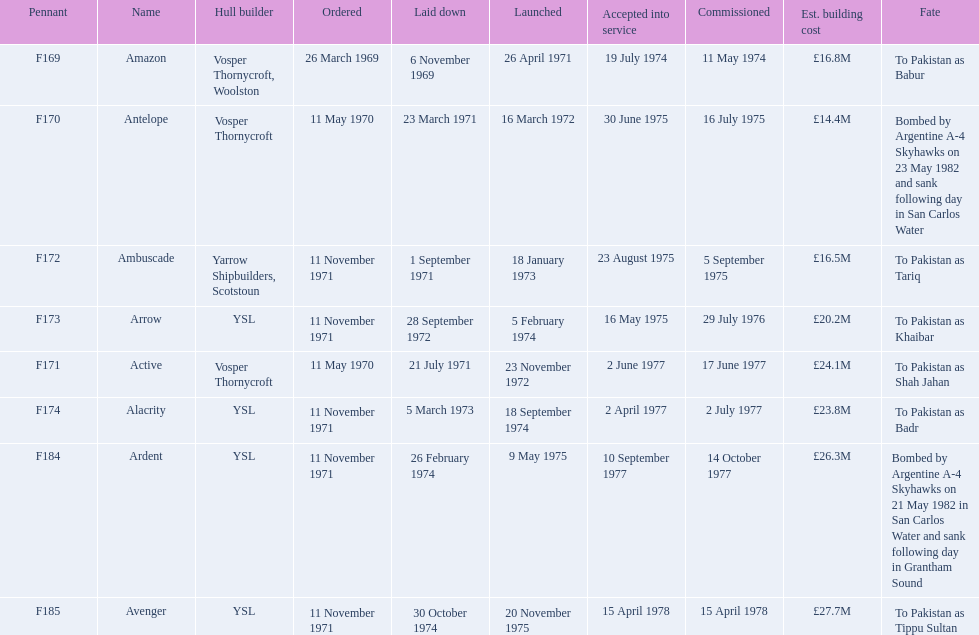Which ships cost more than ps25.0m to build? Ardent, Avenger. Of the ships listed in the answer above, which one cost the most to build? Avenger. 